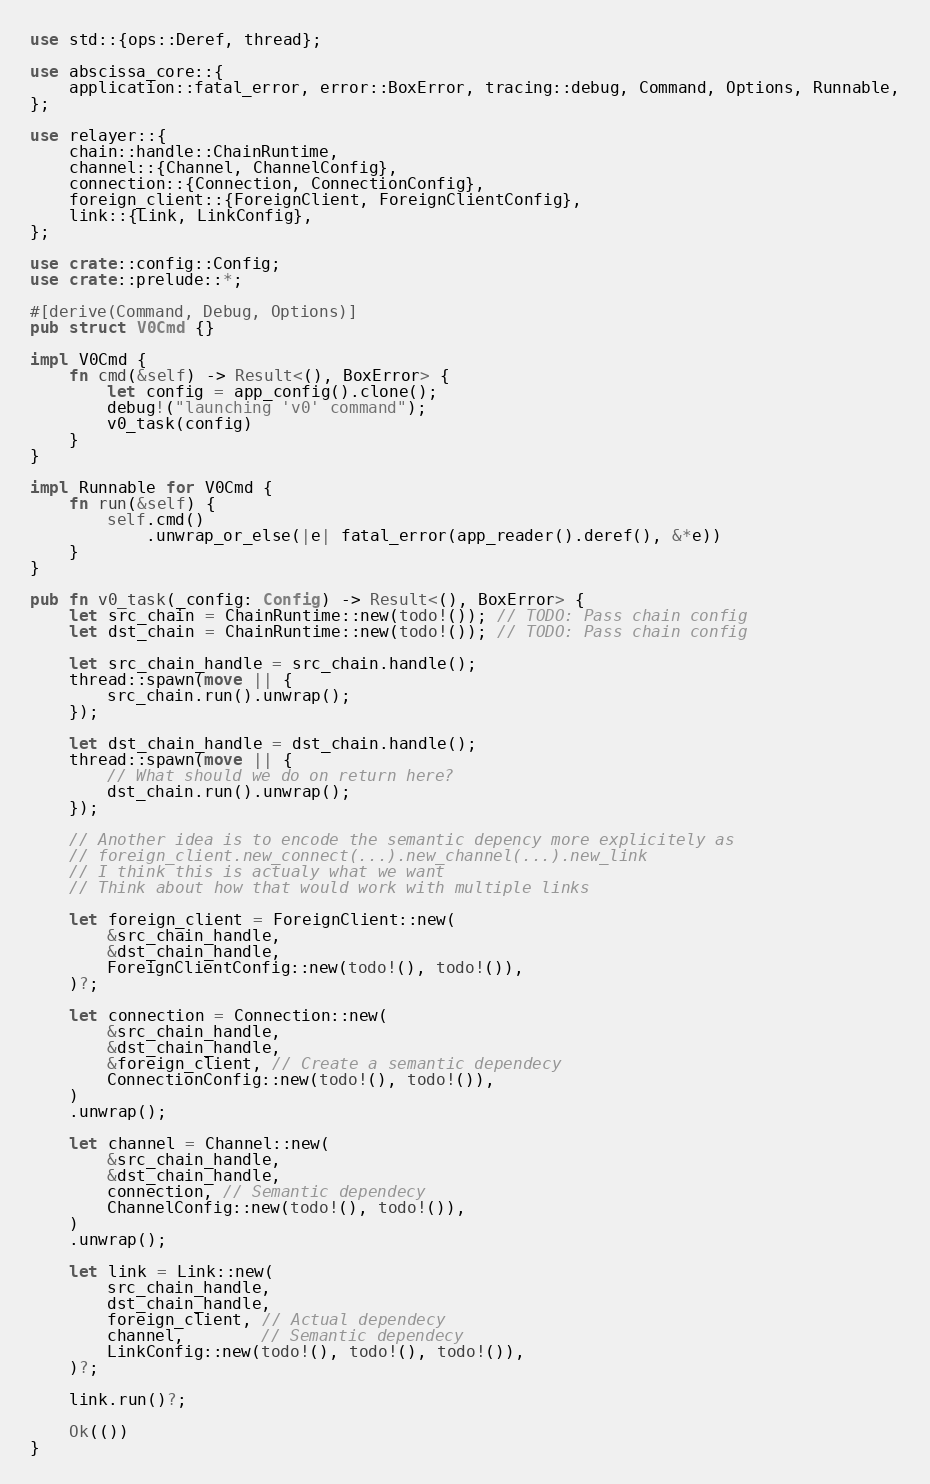<code> <loc_0><loc_0><loc_500><loc_500><_Rust_>use std::{ops::Deref, thread};

use abscissa_core::{
    application::fatal_error, error::BoxError, tracing::debug, Command, Options, Runnable,
};

use relayer::{
    chain::handle::ChainRuntime,
    channel::{Channel, ChannelConfig},
    connection::{Connection, ConnectionConfig},
    foreign_client::{ForeignClient, ForeignClientConfig},
    link::{Link, LinkConfig},
};

use crate::config::Config;
use crate::prelude::*;

#[derive(Command, Debug, Options)]
pub struct V0Cmd {}

impl V0Cmd {
    fn cmd(&self) -> Result<(), BoxError> {
        let config = app_config().clone();
        debug!("launching 'v0' command");
        v0_task(config)
    }
}

impl Runnable for V0Cmd {
    fn run(&self) {
        self.cmd()
            .unwrap_or_else(|e| fatal_error(app_reader().deref(), &*e))
    }
}

pub fn v0_task(_config: Config) -> Result<(), BoxError> {
    let src_chain = ChainRuntime::new(todo!()); // TODO: Pass chain config
    let dst_chain = ChainRuntime::new(todo!()); // TODO: Pass chain config

    let src_chain_handle = src_chain.handle();
    thread::spawn(move || {
        src_chain.run().unwrap();
    });

    let dst_chain_handle = dst_chain.handle();
    thread::spawn(move || {
        // What should we do on return here?
        dst_chain.run().unwrap();
    });

    // Another idea is to encode the semantic depency more explicitely as
    // foreign_client.new_connect(...).new_channel(...).new_link
    // I think this is actualy what we want
    // Think about how that would work with multiple links

    let foreign_client = ForeignClient::new(
        &src_chain_handle,
        &dst_chain_handle,
        ForeignClientConfig::new(todo!(), todo!()),
    )?;

    let connection = Connection::new(
        &src_chain_handle,
        &dst_chain_handle,
        &foreign_client, // Create a semantic dependecy
        ConnectionConfig::new(todo!(), todo!()),
    )
    .unwrap();

    let channel = Channel::new(
        &src_chain_handle,
        &dst_chain_handle,
        connection, // Semantic dependecy
        ChannelConfig::new(todo!(), todo!()),
    )
    .unwrap();

    let link = Link::new(
        src_chain_handle,
        dst_chain_handle,
        foreign_client, // Actual dependecy
        channel,        // Semantic dependecy
        LinkConfig::new(todo!(), todo!(), todo!()),
    )?;

    link.run()?;

    Ok(())
}
</code> 